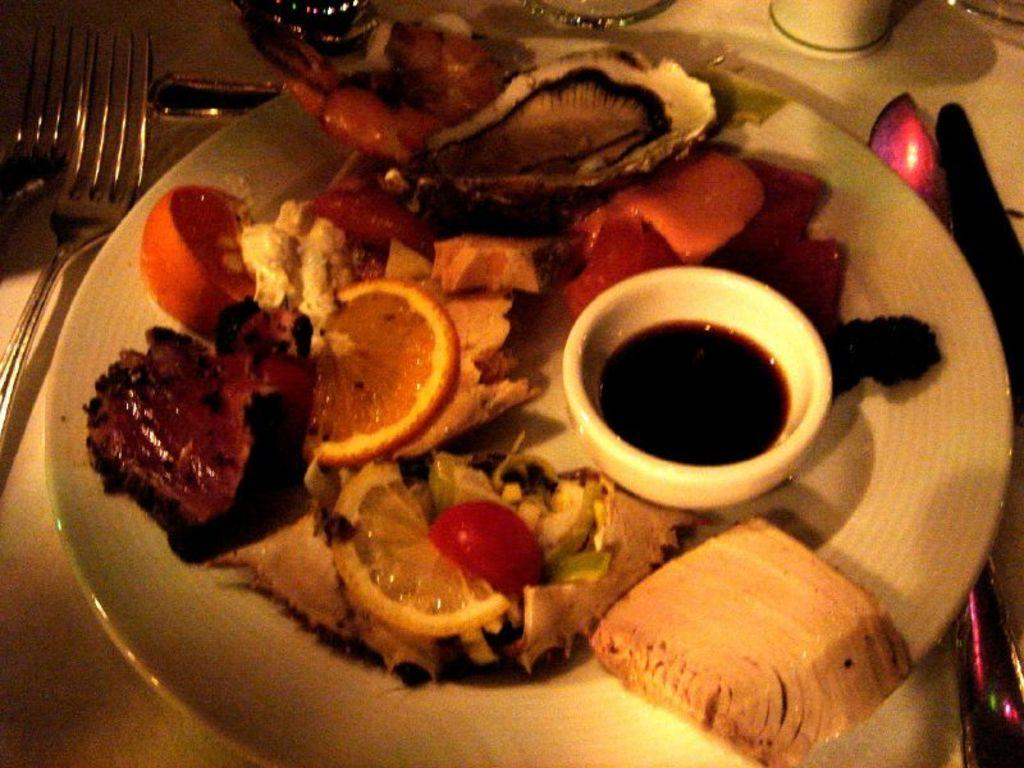What types of food are on the plate in the image? There are fruits and vegetables in a plate in the image. Where is the plate located? The plate is placed on a table. What utensils are visible on the left side of the image? There are forks on the left side of the image. What utensil is visible on the right side of the image? There is a knife on the right side of the image. What stage of development can be seen in the image? There is no developmental stage present in the image; it features a plate of fruits and vegetables, utensils, and a table. What type of writing can be seen on the plate in the image? There is no writing present on the plate or in the image. 